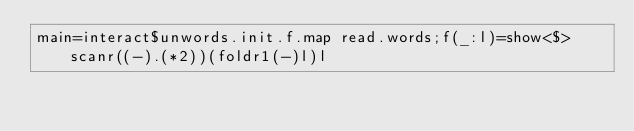<code> <loc_0><loc_0><loc_500><loc_500><_Haskell_>main=interact$unwords.init.f.map read.words;f(_:l)=show<$>scanr((-).(*2))(foldr1(-)l)l</code> 